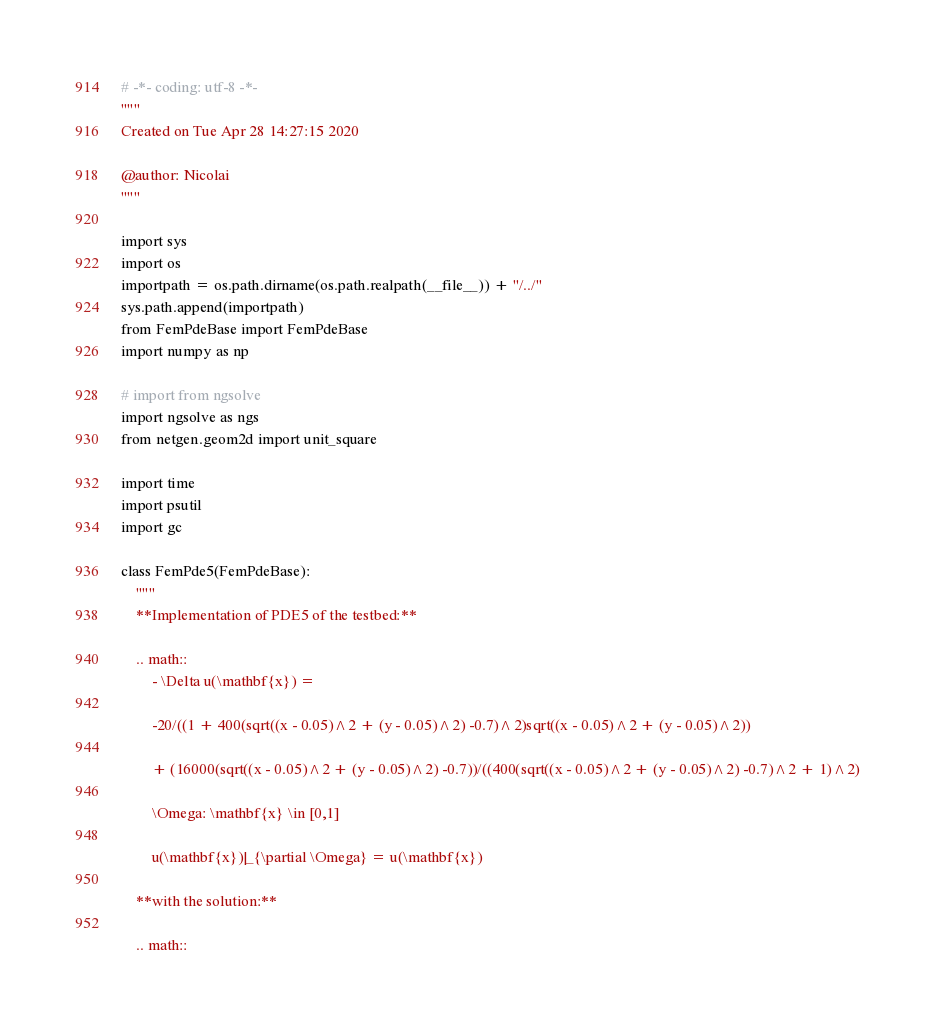<code> <loc_0><loc_0><loc_500><loc_500><_Python_># -*- coding: utf-8 -*-
"""
Created on Tue Apr 28 14:27:15 2020

@author: Nicolai
"""

import sys
import os
importpath = os.path.dirname(os.path.realpath(__file__)) + "/../"
sys.path.append(importpath)
from FemPdeBase import FemPdeBase
import numpy as np

# import from ngsolve
import ngsolve as ngs
from netgen.geom2d import unit_square

import time
import psutil
import gc

class FemPde5(FemPdeBase):
    """
    **Implementation of PDE5 of the testbed:** 
        
    .. math:: 
        - \Delta u(\mathbf{x}) = 
        
        -20/((1 + 400(sqrt((x - 0.05)^2 + (y - 0.05)^2) -0.7)^2)sqrt((x - 0.05)^2 + (y - 0.05)^2)) 
        
        + (16000(sqrt((x - 0.05)^2 + (y - 0.05)^2) -0.7))/((400(sqrt((x - 0.05)^2 + (y - 0.05)^2) -0.7)^2 + 1)^2)
        
        \Omega: \mathbf{x} \in [0,1]
        
        u(\mathbf{x})|_{\partial \Omega} = u(\mathbf{x})
    
    **with the solution:** 
        
    .. math:: </code> 